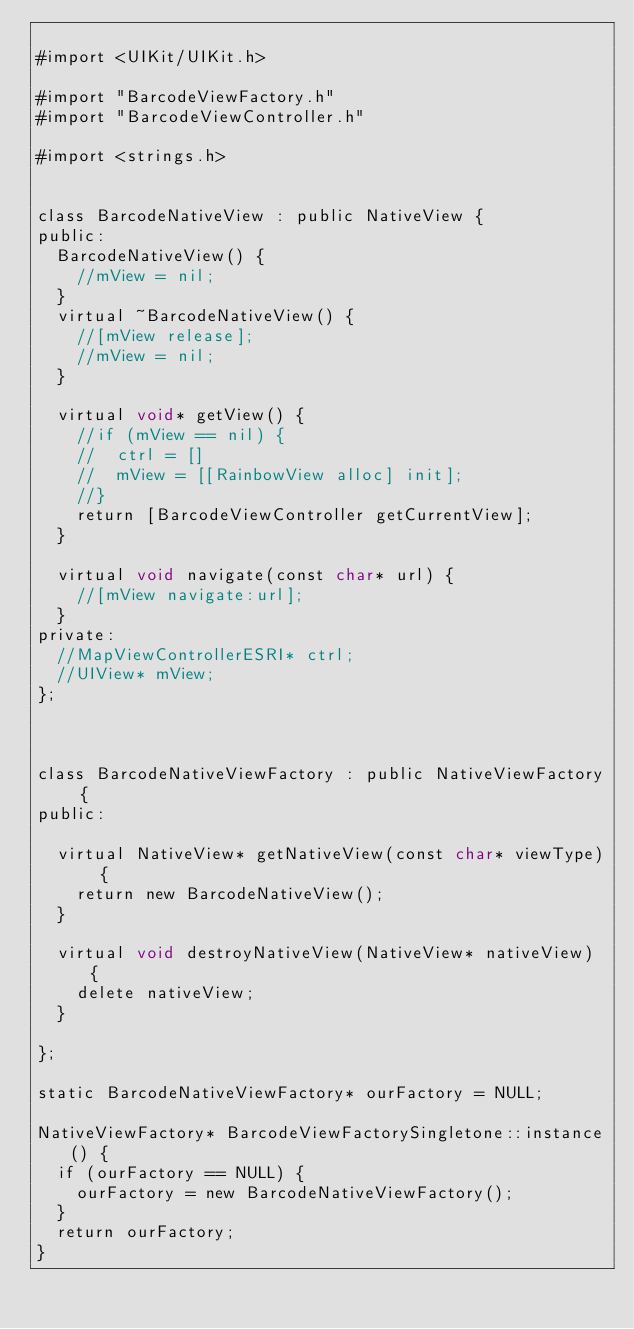<code> <loc_0><loc_0><loc_500><loc_500><_ObjectiveC_>
#import <UIKit/UIKit.h>

#import "BarcodeViewFactory.h"
#import "BarcodeViewController.h"

#import <strings.h>


class BarcodeNativeView : public NativeView {
public:
	BarcodeNativeView() {
		//mView = nil;
	}
	virtual ~BarcodeNativeView() {
		//[mView release];
		//mView = nil;
	}
	
	virtual void* getView() {
		//if (mView == nil) {
		//	ctrl = []
		//	mView = [[RainbowView alloc] init];
		//}
		return [BarcodeViewController getCurrentView];
	}
	
	virtual void navigate(const char* url) {
		//[mView navigate:url];
	}
private:
	//MapViewControllerESRI* ctrl;
	//UIView* mView;
};



class BarcodeNativeViewFactory : public NativeViewFactory {
public:
	
	virtual NativeView* getNativeView(const char* viewType) {
		return new BarcodeNativeView();
	}
	
	virtual void destroyNativeView(NativeView* nativeView) {
		delete nativeView;
	}
	
};

static BarcodeNativeViewFactory* ourFactory = NULL; 

NativeViewFactory* BarcodeViewFactorySingletone::instance() {
	if (ourFactory == NULL) {
		ourFactory = new BarcodeNativeViewFactory();
	}
	return ourFactory;
}
</code> 